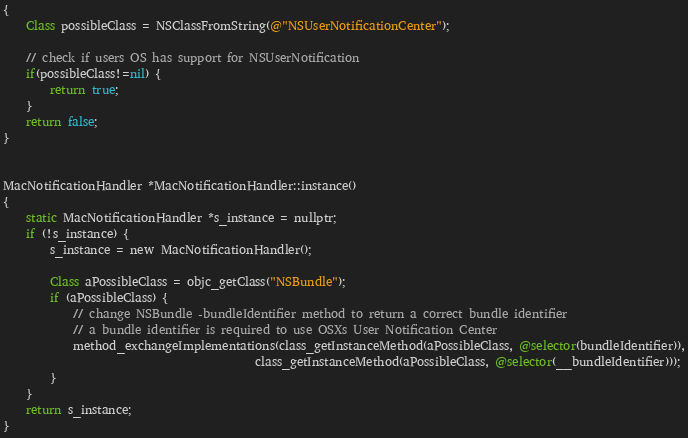<code> <loc_0><loc_0><loc_500><loc_500><_ObjectiveC_>{
    Class possibleClass = NSClassFromString(@"NSUserNotificationCenter");

    // check if users OS has support for NSUserNotification
    if(possibleClass!=nil) {
        return true;
    }
    return false;
}


MacNotificationHandler *MacNotificationHandler::instance()
{
    static MacNotificationHandler *s_instance = nullptr;
    if (!s_instance) {
        s_instance = new MacNotificationHandler();

        Class aPossibleClass = objc_getClass("NSBundle");
        if (aPossibleClass) {
            // change NSBundle -bundleIdentifier method to return a correct bundle identifier
            // a bundle identifier is required to use OSXs User Notification Center
            method_exchangeImplementations(class_getInstanceMethod(aPossibleClass, @selector(bundleIdentifier)),
                                           class_getInstanceMethod(aPossibleClass, @selector(__bundleIdentifier)));
        }
    }
    return s_instance;
}
</code> 